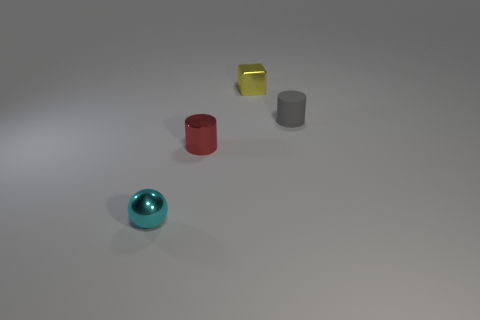Add 3 red metallic objects. How many objects exist? 7 Subtract all cubes. How many objects are left? 3 Subtract 0 green balls. How many objects are left? 4 Subtract all cylinders. Subtract all small yellow metallic cubes. How many objects are left? 1 Add 4 shiny blocks. How many shiny blocks are left? 5 Add 2 tiny blue things. How many tiny blue things exist? 2 